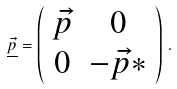<formula> <loc_0><loc_0><loc_500><loc_500>\underline { \vec { p } } = \left ( \begin{array} { c c } \vec { p } & 0 \\ 0 & - \vec { p } * \end{array} \right ) \, .</formula> 